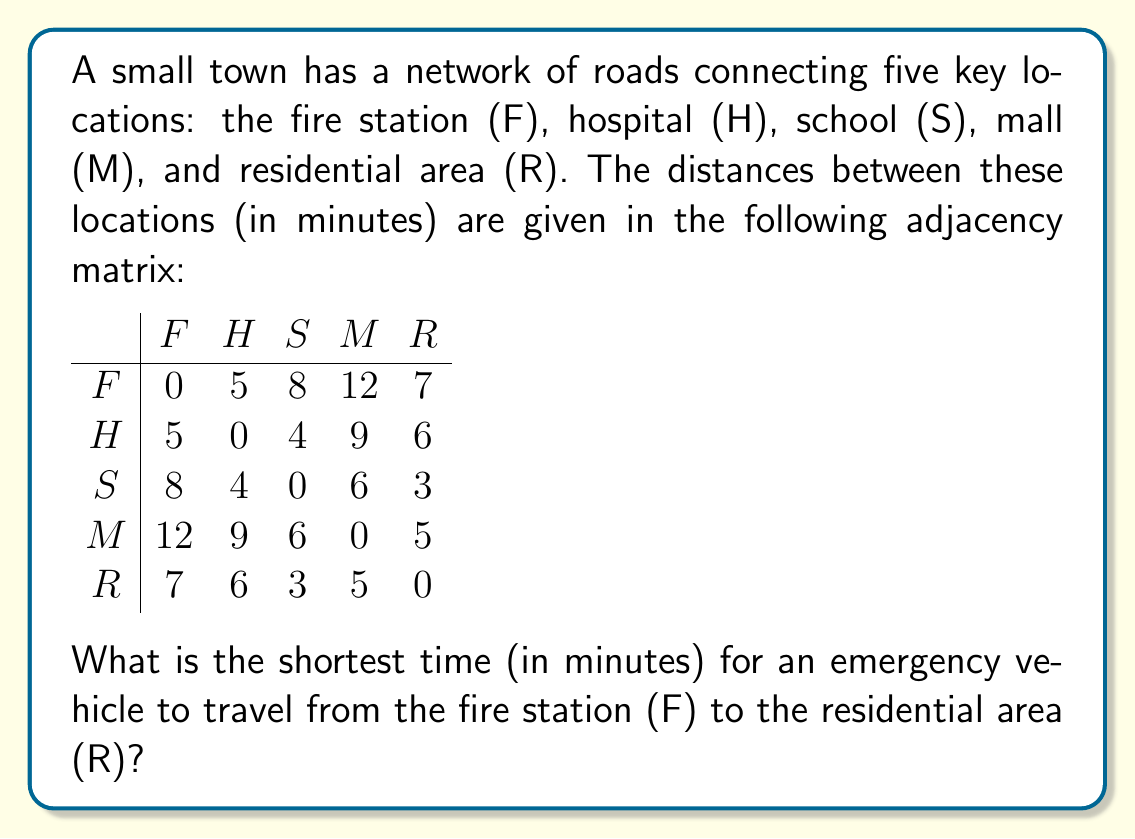Give your solution to this math problem. To find the shortest path from the fire station (F) to the residential area (R), we can use Dijkstra's algorithm. However, for this small network, we can also check all possible paths:

1. Direct path: F → R = 7 minutes

2. Two-step paths:
   F → H → R = 5 + 6 = 11 minutes
   F → S → R = 8 + 3 = 11 minutes
   F → M → R = 12 + 5 = 17 minutes

3. Three-step paths:
   F → H → S → R = 5 + 4 + 3 = 12 minutes
   F → S → M → R = 8 + 6 + 5 = 19 minutes

4. Four-step path:
   F → H → S → M → R = 5 + 4 + 6 + 5 = 20 minutes

The shortest path is the direct route from F to R, which takes 7 minutes.

This problem demonstrates the importance of efficient route planning for emergency vehicles, a crucial skill for firefighters and other emergency responders.
Answer: 7 minutes 